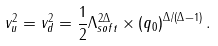<formula> <loc_0><loc_0><loc_500><loc_500>v _ { u } ^ { 2 } = v _ { d } ^ { 2 } = \frac { 1 } { 2 } \Lambda _ { s o f t } ^ { 2 \Delta } \times \left ( q _ { 0 } \right ) ^ { \Delta / ( \Delta - 1 ) } .</formula> 